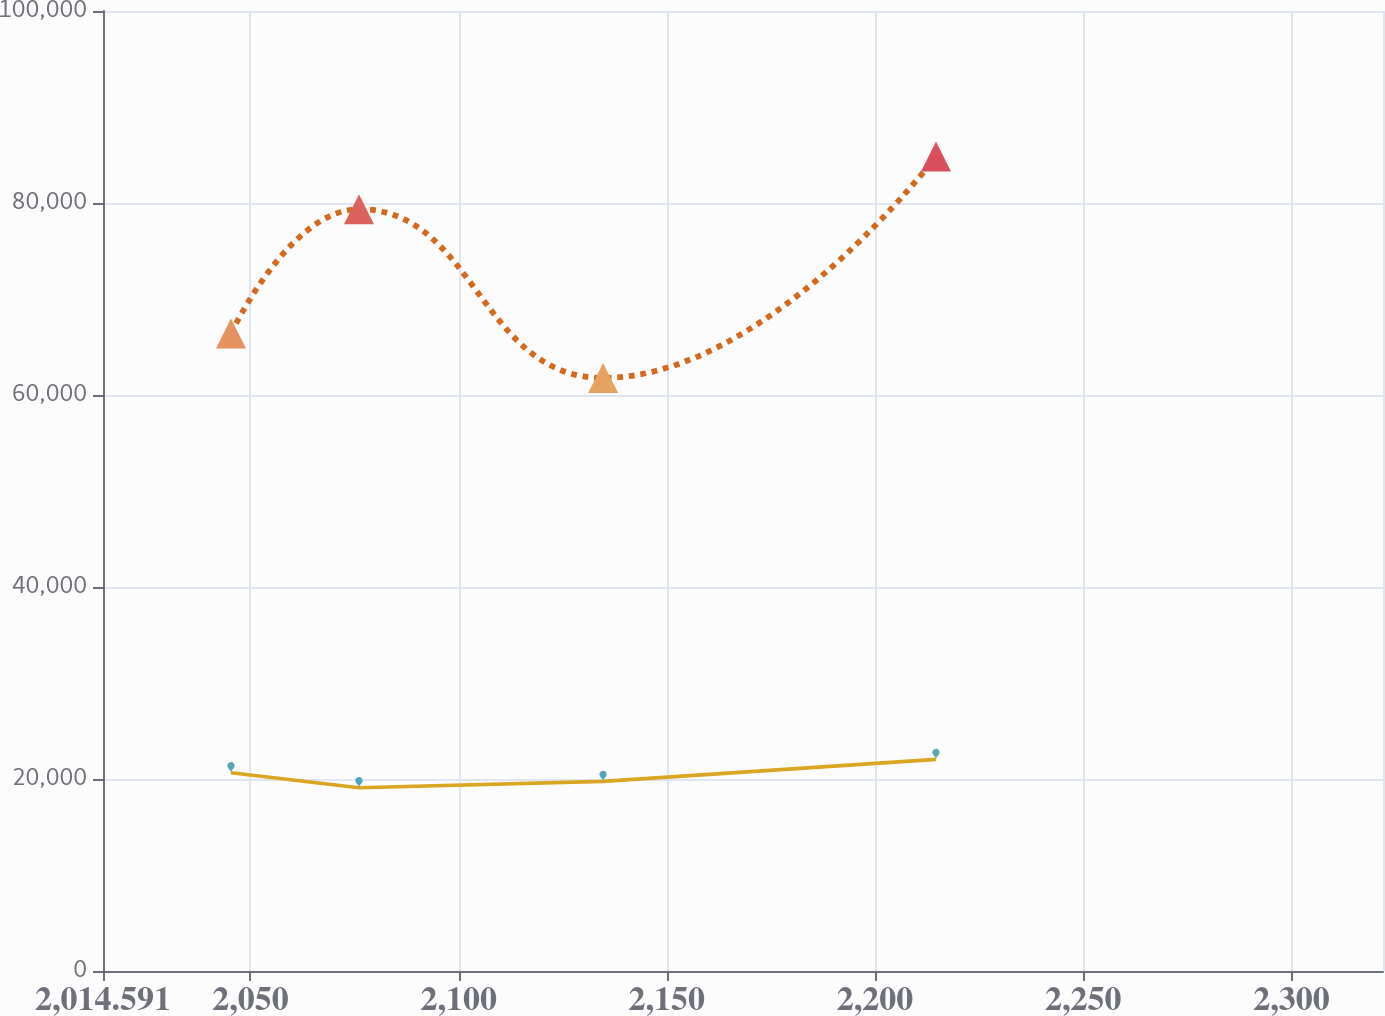Convert chart to OTSL. <chart><loc_0><loc_0><loc_500><loc_500><line_chart><ecel><fcel>Post-retirement Benefits<fcel>Pension Benefits<nl><fcel>2045.33<fcel>66395.7<fcel>20654.5<nl><fcel>2076.07<fcel>79356.3<fcel>19095.5<nl><fcel>2134.69<fcel>61780.9<fcel>19748<nl><fcel>2214.64<fcel>84854.9<fcel>22045.9<nl><fcel>2352.72<fcel>64088.3<fcel>23528.2<nl></chart> 